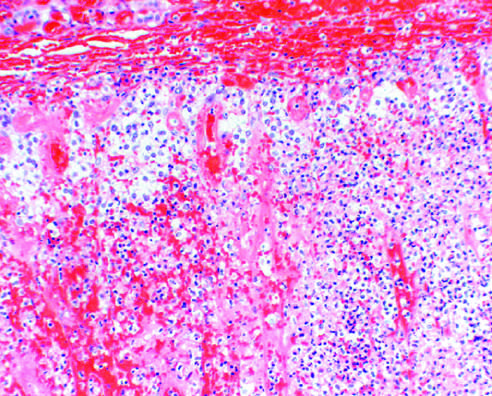s the tissue discernible in this photomicrograph?
Answer the question using a single word or phrase. No 